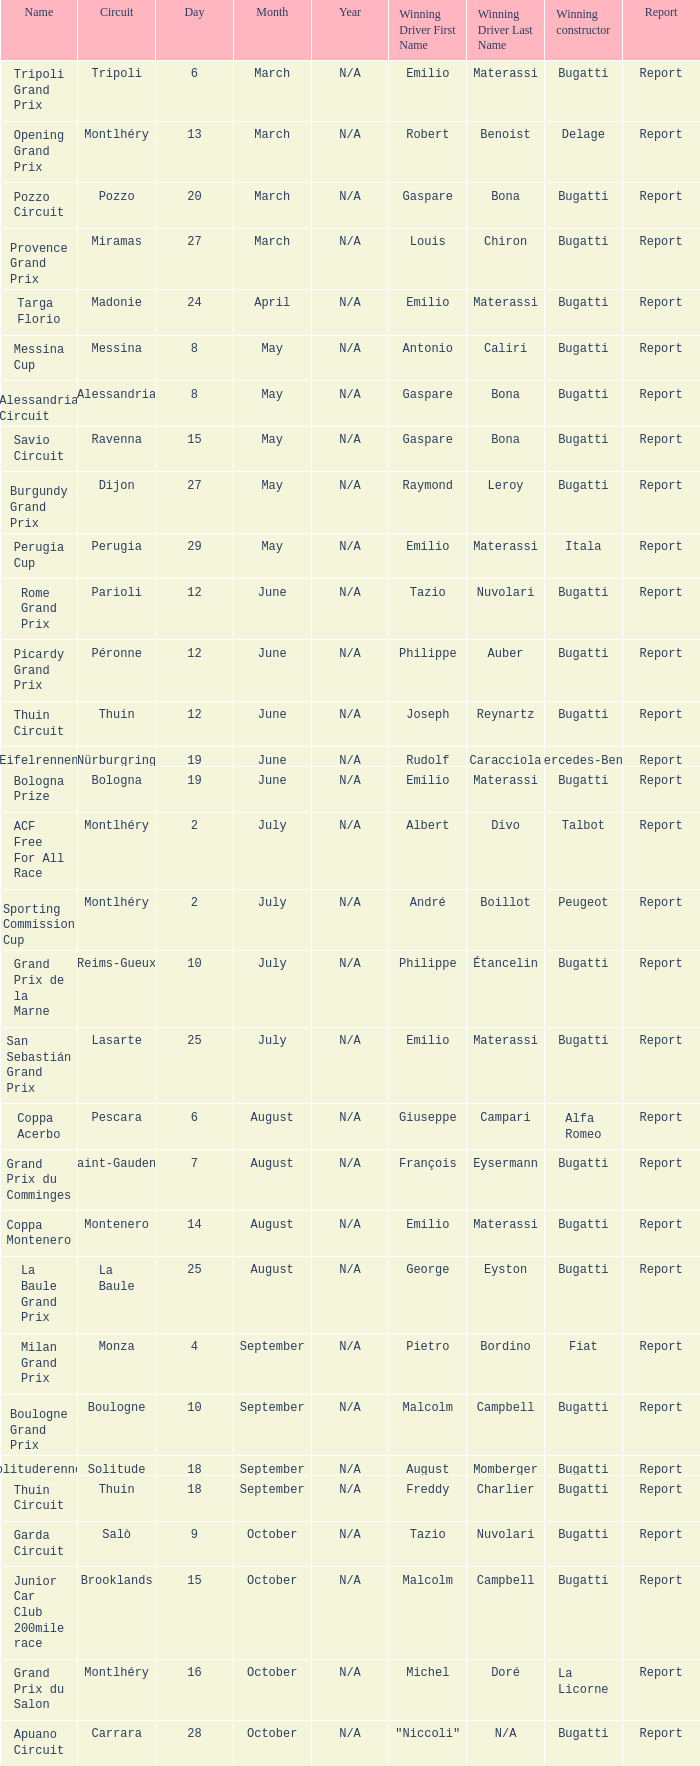Who was the winning constructor at the circuit of parioli? Bugatti. 